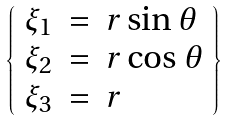<formula> <loc_0><loc_0><loc_500><loc_500>\left \{ \begin{array} { l l l } \xi _ { 1 } & = & r \sin \theta \\ \xi _ { 2 } & = & r \cos \theta \\ \xi _ { 3 } & = & r \end{array} \right \}</formula> 